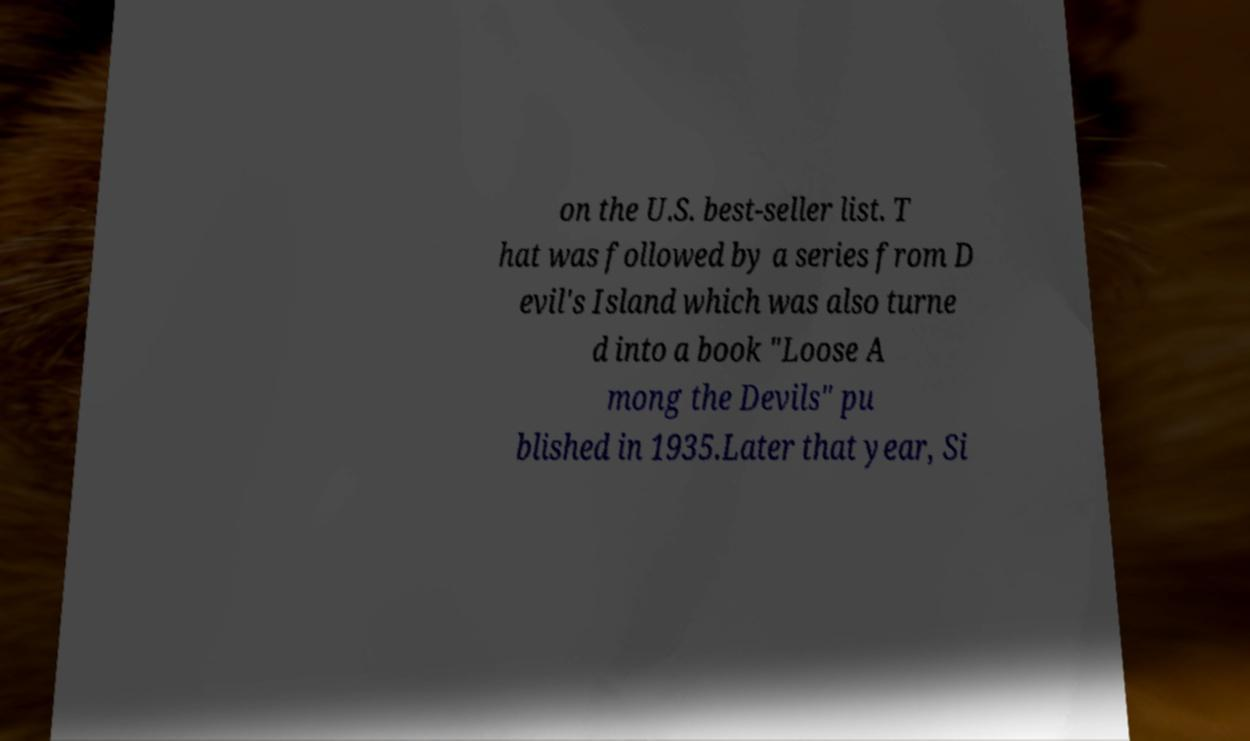I need the written content from this picture converted into text. Can you do that? on the U.S. best-seller list. T hat was followed by a series from D evil's Island which was also turne d into a book "Loose A mong the Devils" pu blished in 1935.Later that year, Si 